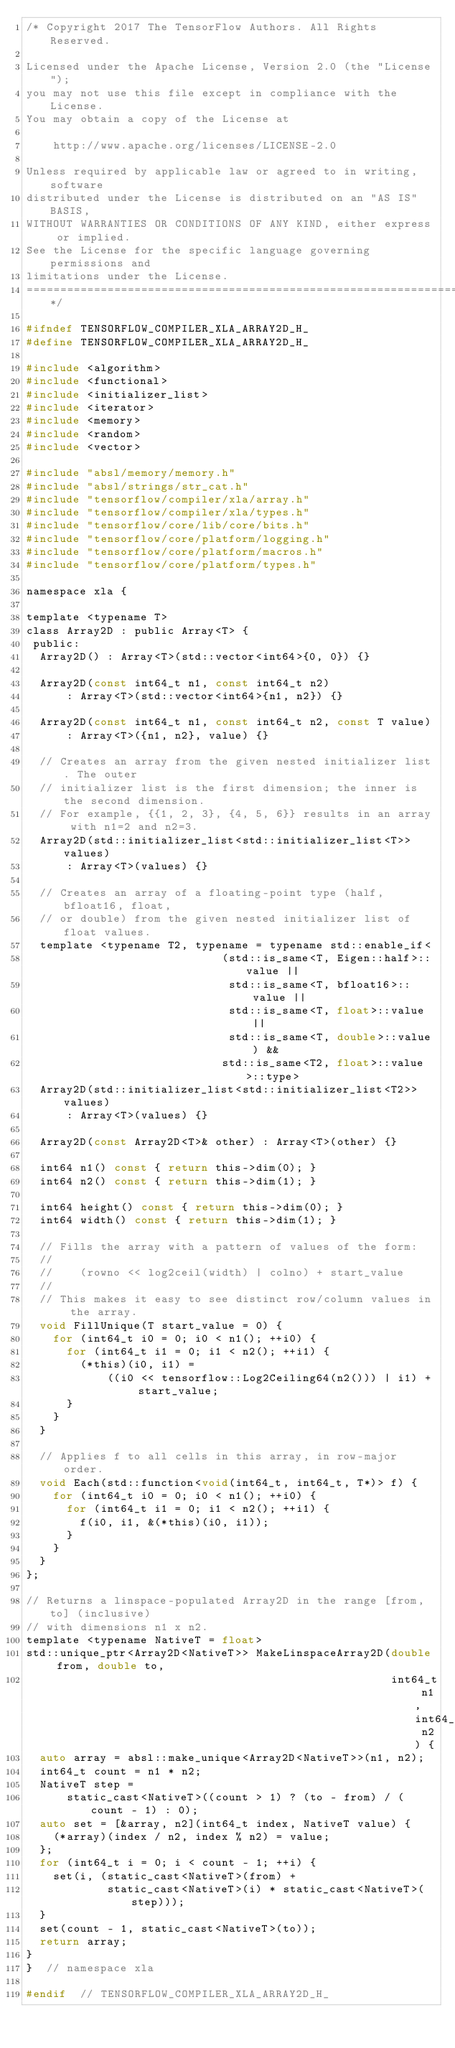Convert code to text. <code><loc_0><loc_0><loc_500><loc_500><_C_>/* Copyright 2017 The TensorFlow Authors. All Rights Reserved.

Licensed under the Apache License, Version 2.0 (the "License");
you may not use this file except in compliance with the License.
You may obtain a copy of the License at

    http://www.apache.org/licenses/LICENSE-2.0

Unless required by applicable law or agreed to in writing, software
distributed under the License is distributed on an "AS IS" BASIS,
WITHOUT WARRANTIES OR CONDITIONS OF ANY KIND, either express or implied.
See the License for the specific language governing permissions and
limitations under the License.
==============================================================================*/

#ifndef TENSORFLOW_COMPILER_XLA_ARRAY2D_H_
#define TENSORFLOW_COMPILER_XLA_ARRAY2D_H_

#include <algorithm>
#include <functional>
#include <initializer_list>
#include <iterator>
#include <memory>
#include <random>
#include <vector>

#include "absl/memory/memory.h"
#include "absl/strings/str_cat.h"
#include "tensorflow/compiler/xla/array.h"
#include "tensorflow/compiler/xla/types.h"
#include "tensorflow/core/lib/core/bits.h"
#include "tensorflow/core/platform/logging.h"
#include "tensorflow/core/platform/macros.h"
#include "tensorflow/core/platform/types.h"

namespace xla {

template <typename T>
class Array2D : public Array<T> {
 public:
  Array2D() : Array<T>(std::vector<int64>{0, 0}) {}

  Array2D(const int64_t n1, const int64_t n2)
      : Array<T>(std::vector<int64>{n1, n2}) {}

  Array2D(const int64_t n1, const int64_t n2, const T value)
      : Array<T>({n1, n2}, value) {}

  // Creates an array from the given nested initializer list. The outer
  // initializer list is the first dimension; the inner is the second dimension.
  // For example, {{1, 2, 3}, {4, 5, 6}} results in an array with n1=2 and n2=3.
  Array2D(std::initializer_list<std::initializer_list<T>> values)
      : Array<T>(values) {}

  // Creates an array of a floating-point type (half, bfloat16, float,
  // or double) from the given nested initializer list of float values.
  template <typename T2, typename = typename std::enable_if<
                             (std::is_same<T, Eigen::half>::value ||
                              std::is_same<T, bfloat16>::value ||
                              std::is_same<T, float>::value ||
                              std::is_same<T, double>::value) &&
                             std::is_same<T2, float>::value>::type>
  Array2D(std::initializer_list<std::initializer_list<T2>> values)
      : Array<T>(values) {}

  Array2D(const Array2D<T>& other) : Array<T>(other) {}

  int64 n1() const { return this->dim(0); }
  int64 n2() const { return this->dim(1); }

  int64 height() const { return this->dim(0); }
  int64 width() const { return this->dim(1); }

  // Fills the array with a pattern of values of the form:
  //
  //    (rowno << log2ceil(width) | colno) + start_value
  //
  // This makes it easy to see distinct row/column values in the array.
  void FillUnique(T start_value = 0) {
    for (int64_t i0 = 0; i0 < n1(); ++i0) {
      for (int64_t i1 = 0; i1 < n2(); ++i1) {
        (*this)(i0, i1) =
            ((i0 << tensorflow::Log2Ceiling64(n2())) | i1) + start_value;
      }
    }
  }

  // Applies f to all cells in this array, in row-major order.
  void Each(std::function<void(int64_t, int64_t, T*)> f) {
    for (int64_t i0 = 0; i0 < n1(); ++i0) {
      for (int64_t i1 = 0; i1 < n2(); ++i1) {
        f(i0, i1, &(*this)(i0, i1));
      }
    }
  }
};

// Returns a linspace-populated Array2D in the range [from, to] (inclusive)
// with dimensions n1 x n2.
template <typename NativeT = float>
std::unique_ptr<Array2D<NativeT>> MakeLinspaceArray2D(double from, double to,
                                                      int64_t n1, int64_t n2) {
  auto array = absl::make_unique<Array2D<NativeT>>(n1, n2);
  int64_t count = n1 * n2;
  NativeT step =
      static_cast<NativeT>((count > 1) ? (to - from) / (count - 1) : 0);
  auto set = [&array, n2](int64_t index, NativeT value) {
    (*array)(index / n2, index % n2) = value;
  };
  for (int64_t i = 0; i < count - 1; ++i) {
    set(i, (static_cast<NativeT>(from) +
            static_cast<NativeT>(i) * static_cast<NativeT>(step)));
  }
  set(count - 1, static_cast<NativeT>(to));
  return array;
}
}  // namespace xla

#endif  // TENSORFLOW_COMPILER_XLA_ARRAY2D_H_
</code> 